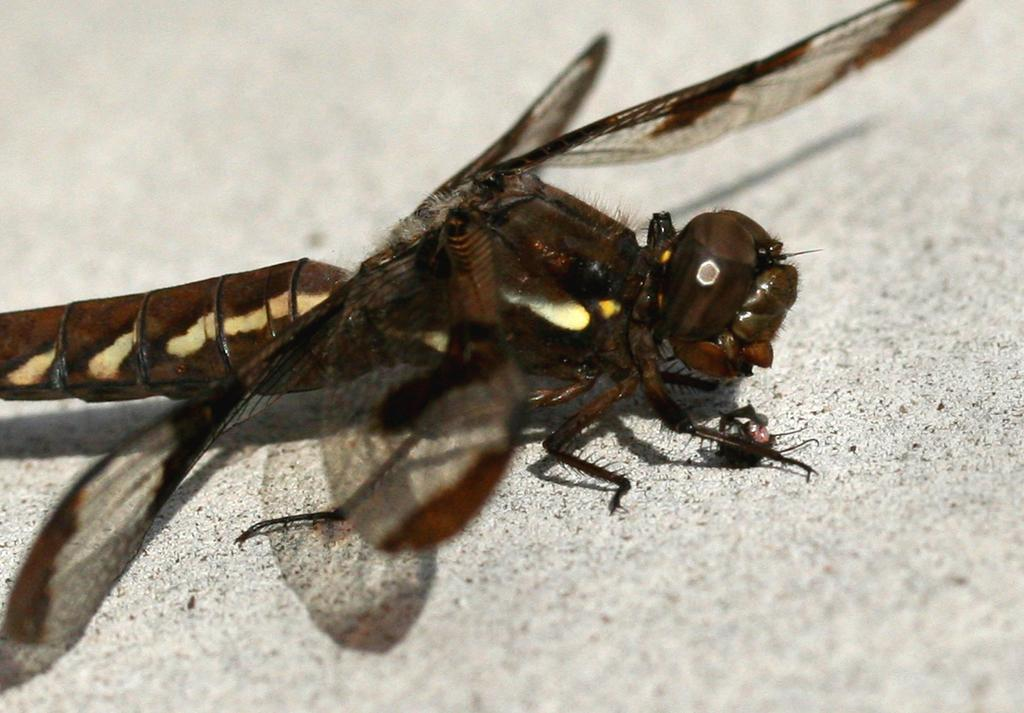What is the main subject of the picture? The main subject of the picture is a dragonfly. Where is the dragonfly located in the image? The dragonfly is on a path in the image. What is the color of the dragonfly? The dragonfly is brown in color. What body parts does the dragonfly have that allow it to fly? The dragonfly has wings in the image. What are two other body parts of the dragonfly that can be seen in the image? The dragonfly has eyes and legs in the image. Reasoning: Let's think step by step by step in order to produce the conversation. We start by identifying the main subject of the image, which is the dragonfly. Then, we describe the location of the dragonfly, its color, and its specific body parts that are visible in the image. We ensure that each question can be answered definitively with the information given and avoid yes/no questions. Absurd Question/Answer: What type of yarn is the dragonfly using to weave a sign in the image? There is no yarn or sign present in the image; it features a dragonfly with wings, eyes, and legs. What type of yarn is the dragonfly using to weave a sign in the image? There is no yarn or sign present in the image; it features a dragonfly with wings, eyes, and legs. 